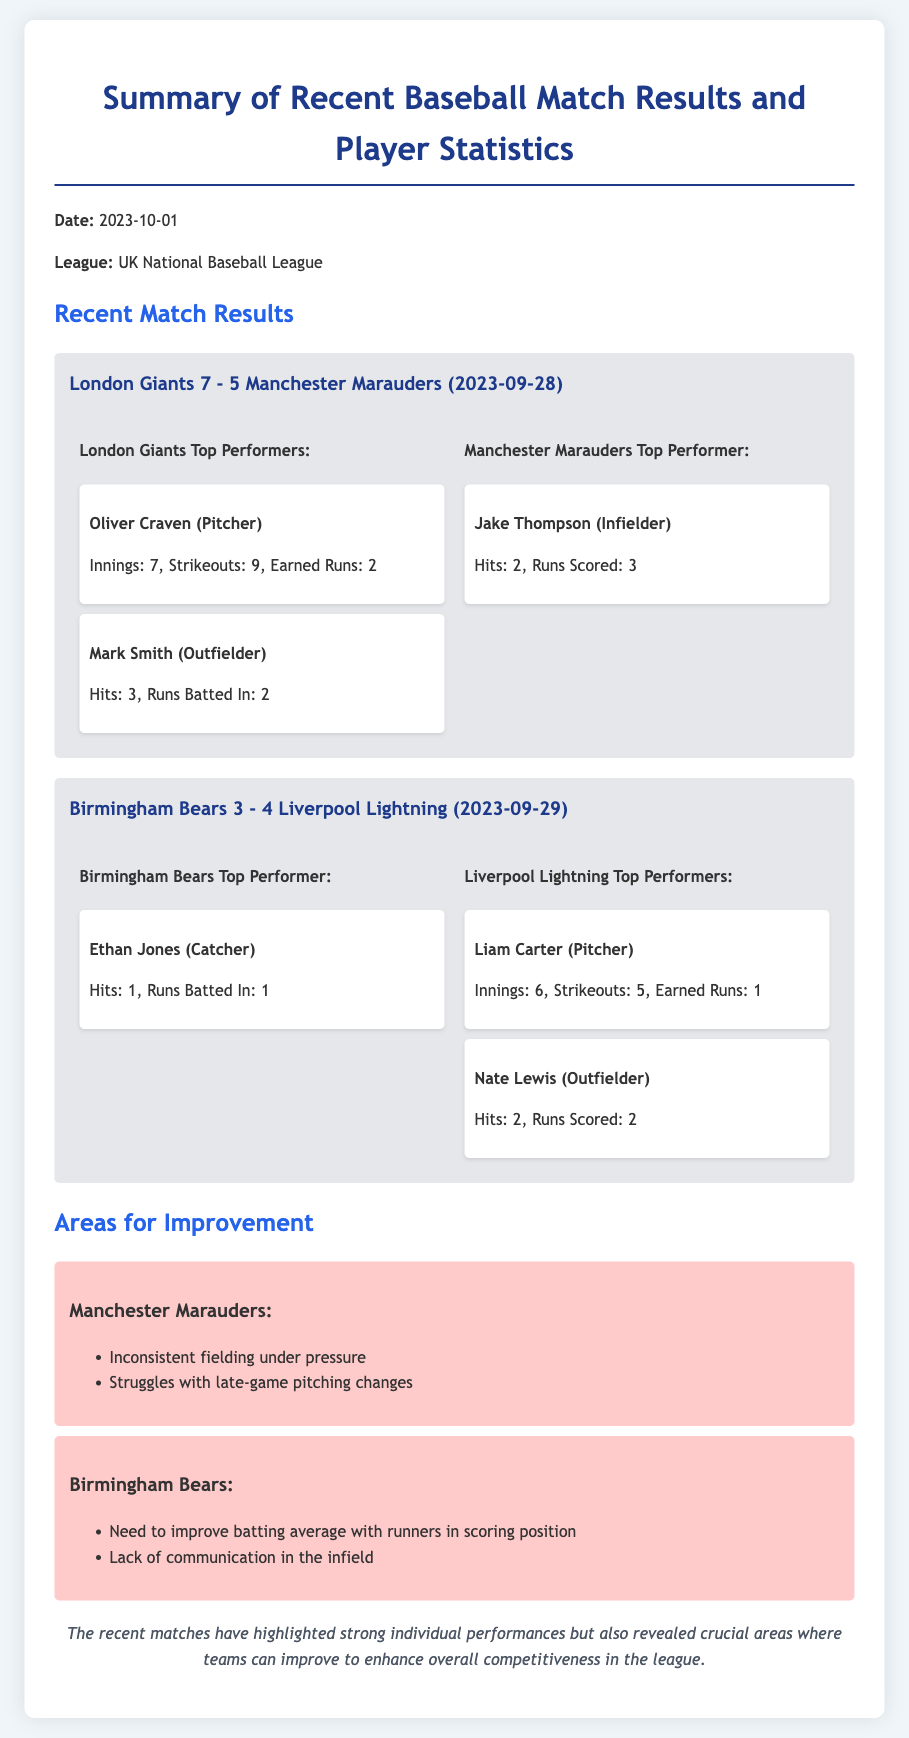What was the date of the recent matches? The date of the recent matches is mentioned at the beginning of the memo, which is 2023-10-01.
Answer: 2023-10-01 Which team won the match between London Giants and Manchester Marauders? This information is found in the match results section where the score indicates that the London Giants won against the Manchester Marauders.
Answer: London Giants Who was the top performer for the Liverpool Lightning? The top performer is noted in the match results, specifically for Liverpool Lightning, which mentions Liam Carter.
Answer: Liam Carter What specific area does the Manchester Marauders need to improve? The memo lists areas for improvement, highlighting "inconsistent fielding under pressure" for the Manchester Marauders.
Answer: Inconsistent fielding under pressure How many strikeouts did Oliver Craven achieve? The statistics for Oliver Craven are included in the performer section specifying the number of strikeouts he had during the match.
Answer: 9 